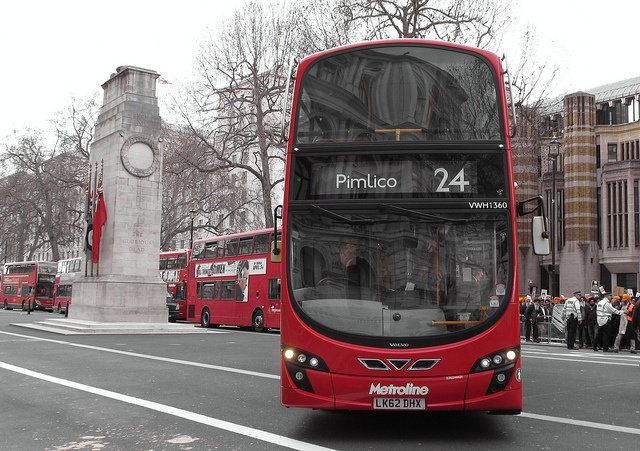Describe the objects in this image and their specific colors. I can see bus in white, black, gray, brown, and maroon tones, bus in white, brown, gray, black, and darkgray tones, bus in white, gray, brown, black, and darkgray tones, people in white, black, and gray tones, and bus in white, gray, maroon, black, and brown tones in this image. 